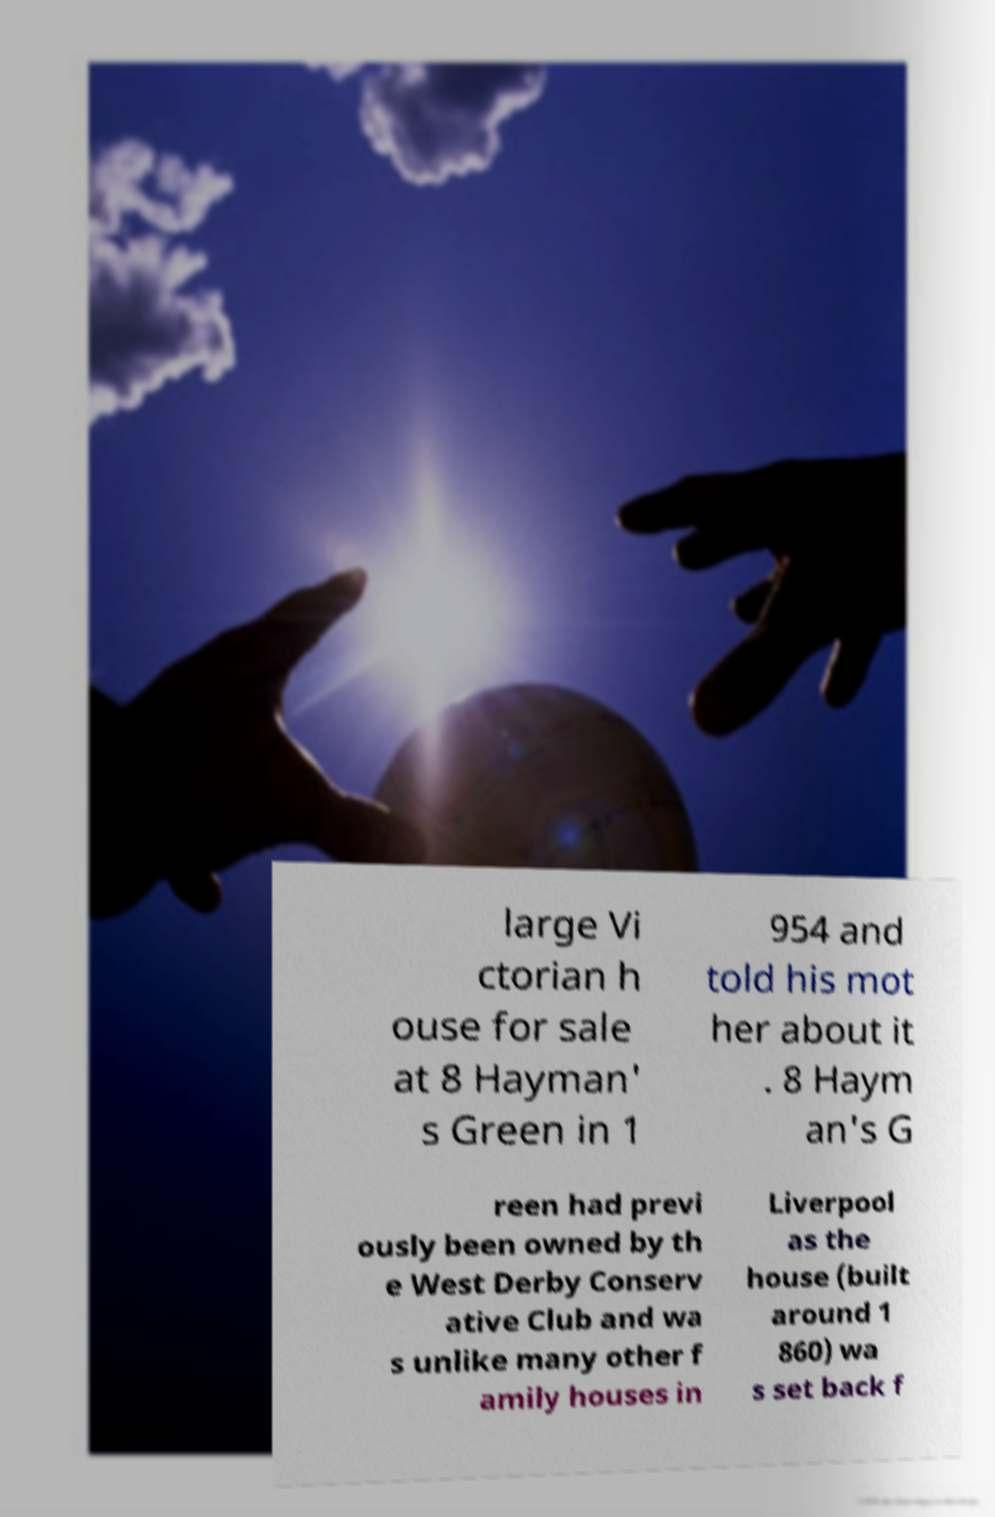There's text embedded in this image that I need extracted. Can you transcribe it verbatim? large Vi ctorian h ouse for sale at 8 Hayman' s Green in 1 954 and told his mot her about it . 8 Haym an's G reen had previ ously been owned by th e West Derby Conserv ative Club and wa s unlike many other f amily houses in Liverpool as the house (built around 1 860) wa s set back f 